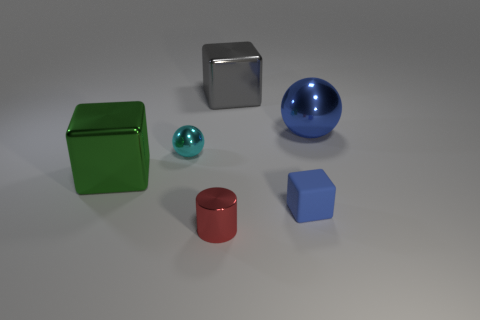How many big things are either purple metallic objects or blue matte blocks?
Ensure brevity in your answer.  0. Are there any other things that have the same color as the big ball?
Ensure brevity in your answer.  Yes. Are there any tiny blue matte blocks behind the small metal sphere?
Offer a terse response. No. What size is the metal sphere behind the tiny thing behind the large green thing?
Your answer should be very brief. Large. Are there the same number of big objects behind the gray cube and large blue metal spheres behind the blue matte thing?
Your answer should be very brief. No. Are there any green cubes on the right side of the shiny sphere left of the small rubber object?
Provide a succinct answer. No. There is a small metal object in front of the big block that is left of the gray shiny block; what number of big cubes are in front of it?
Ensure brevity in your answer.  0. Are there fewer small purple cylinders than red metal cylinders?
Provide a short and direct response. Yes. There is a blue thing that is in front of the large metallic ball; is it the same shape as the blue object behind the rubber block?
Your answer should be compact. No. What is the color of the tiny cube?
Provide a short and direct response. Blue. 